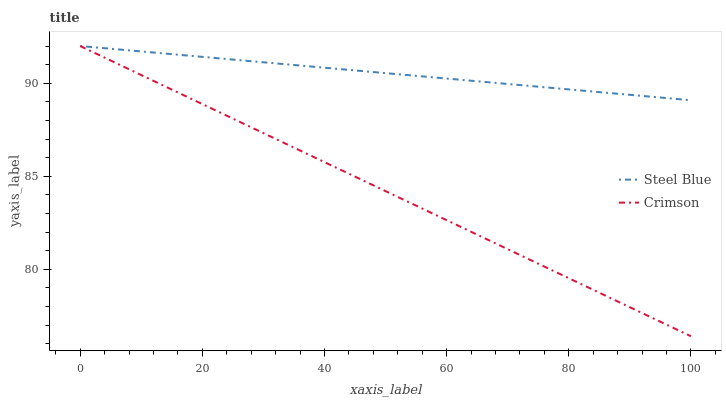Does Crimson have the minimum area under the curve?
Answer yes or no. Yes. Does Steel Blue have the maximum area under the curve?
Answer yes or no. Yes. Does Steel Blue have the minimum area under the curve?
Answer yes or no. No. Is Steel Blue the smoothest?
Answer yes or no. Yes. Is Crimson the roughest?
Answer yes or no. Yes. Is Steel Blue the roughest?
Answer yes or no. No. Does Crimson have the lowest value?
Answer yes or no. Yes. Does Steel Blue have the lowest value?
Answer yes or no. No. Does Steel Blue have the highest value?
Answer yes or no. Yes. Does Crimson intersect Steel Blue?
Answer yes or no. Yes. Is Crimson less than Steel Blue?
Answer yes or no. No. Is Crimson greater than Steel Blue?
Answer yes or no. No. 